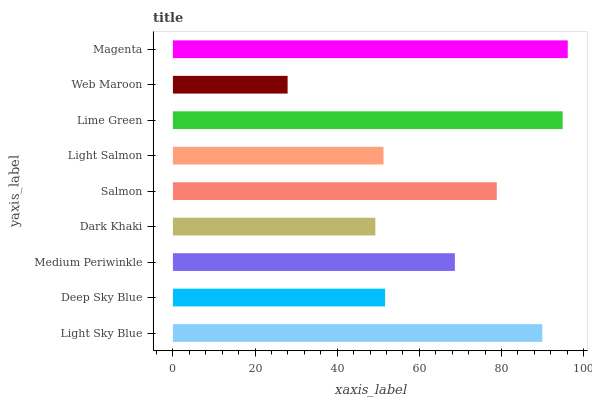Is Web Maroon the minimum?
Answer yes or no. Yes. Is Magenta the maximum?
Answer yes or no. Yes. Is Deep Sky Blue the minimum?
Answer yes or no. No. Is Deep Sky Blue the maximum?
Answer yes or no. No. Is Light Sky Blue greater than Deep Sky Blue?
Answer yes or no. Yes. Is Deep Sky Blue less than Light Sky Blue?
Answer yes or no. Yes. Is Deep Sky Blue greater than Light Sky Blue?
Answer yes or no. No. Is Light Sky Blue less than Deep Sky Blue?
Answer yes or no. No. Is Medium Periwinkle the high median?
Answer yes or no. Yes. Is Medium Periwinkle the low median?
Answer yes or no. Yes. Is Light Salmon the high median?
Answer yes or no. No. Is Magenta the low median?
Answer yes or no. No. 